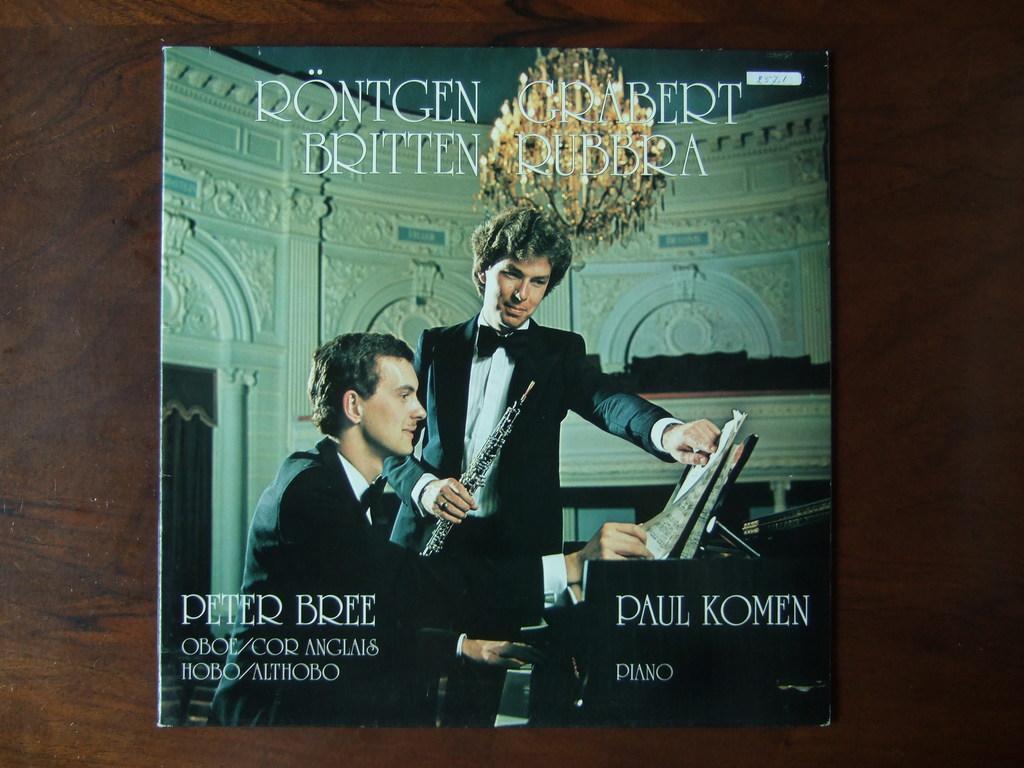Can you describe this image briefly? In this image I can see a pamphlet, in the pamphlet I can see two persons, one person is sitting and the other person is standing. They are wearing black blazer, white shirt and the pamphlet is on the table and the table is in brown color. 